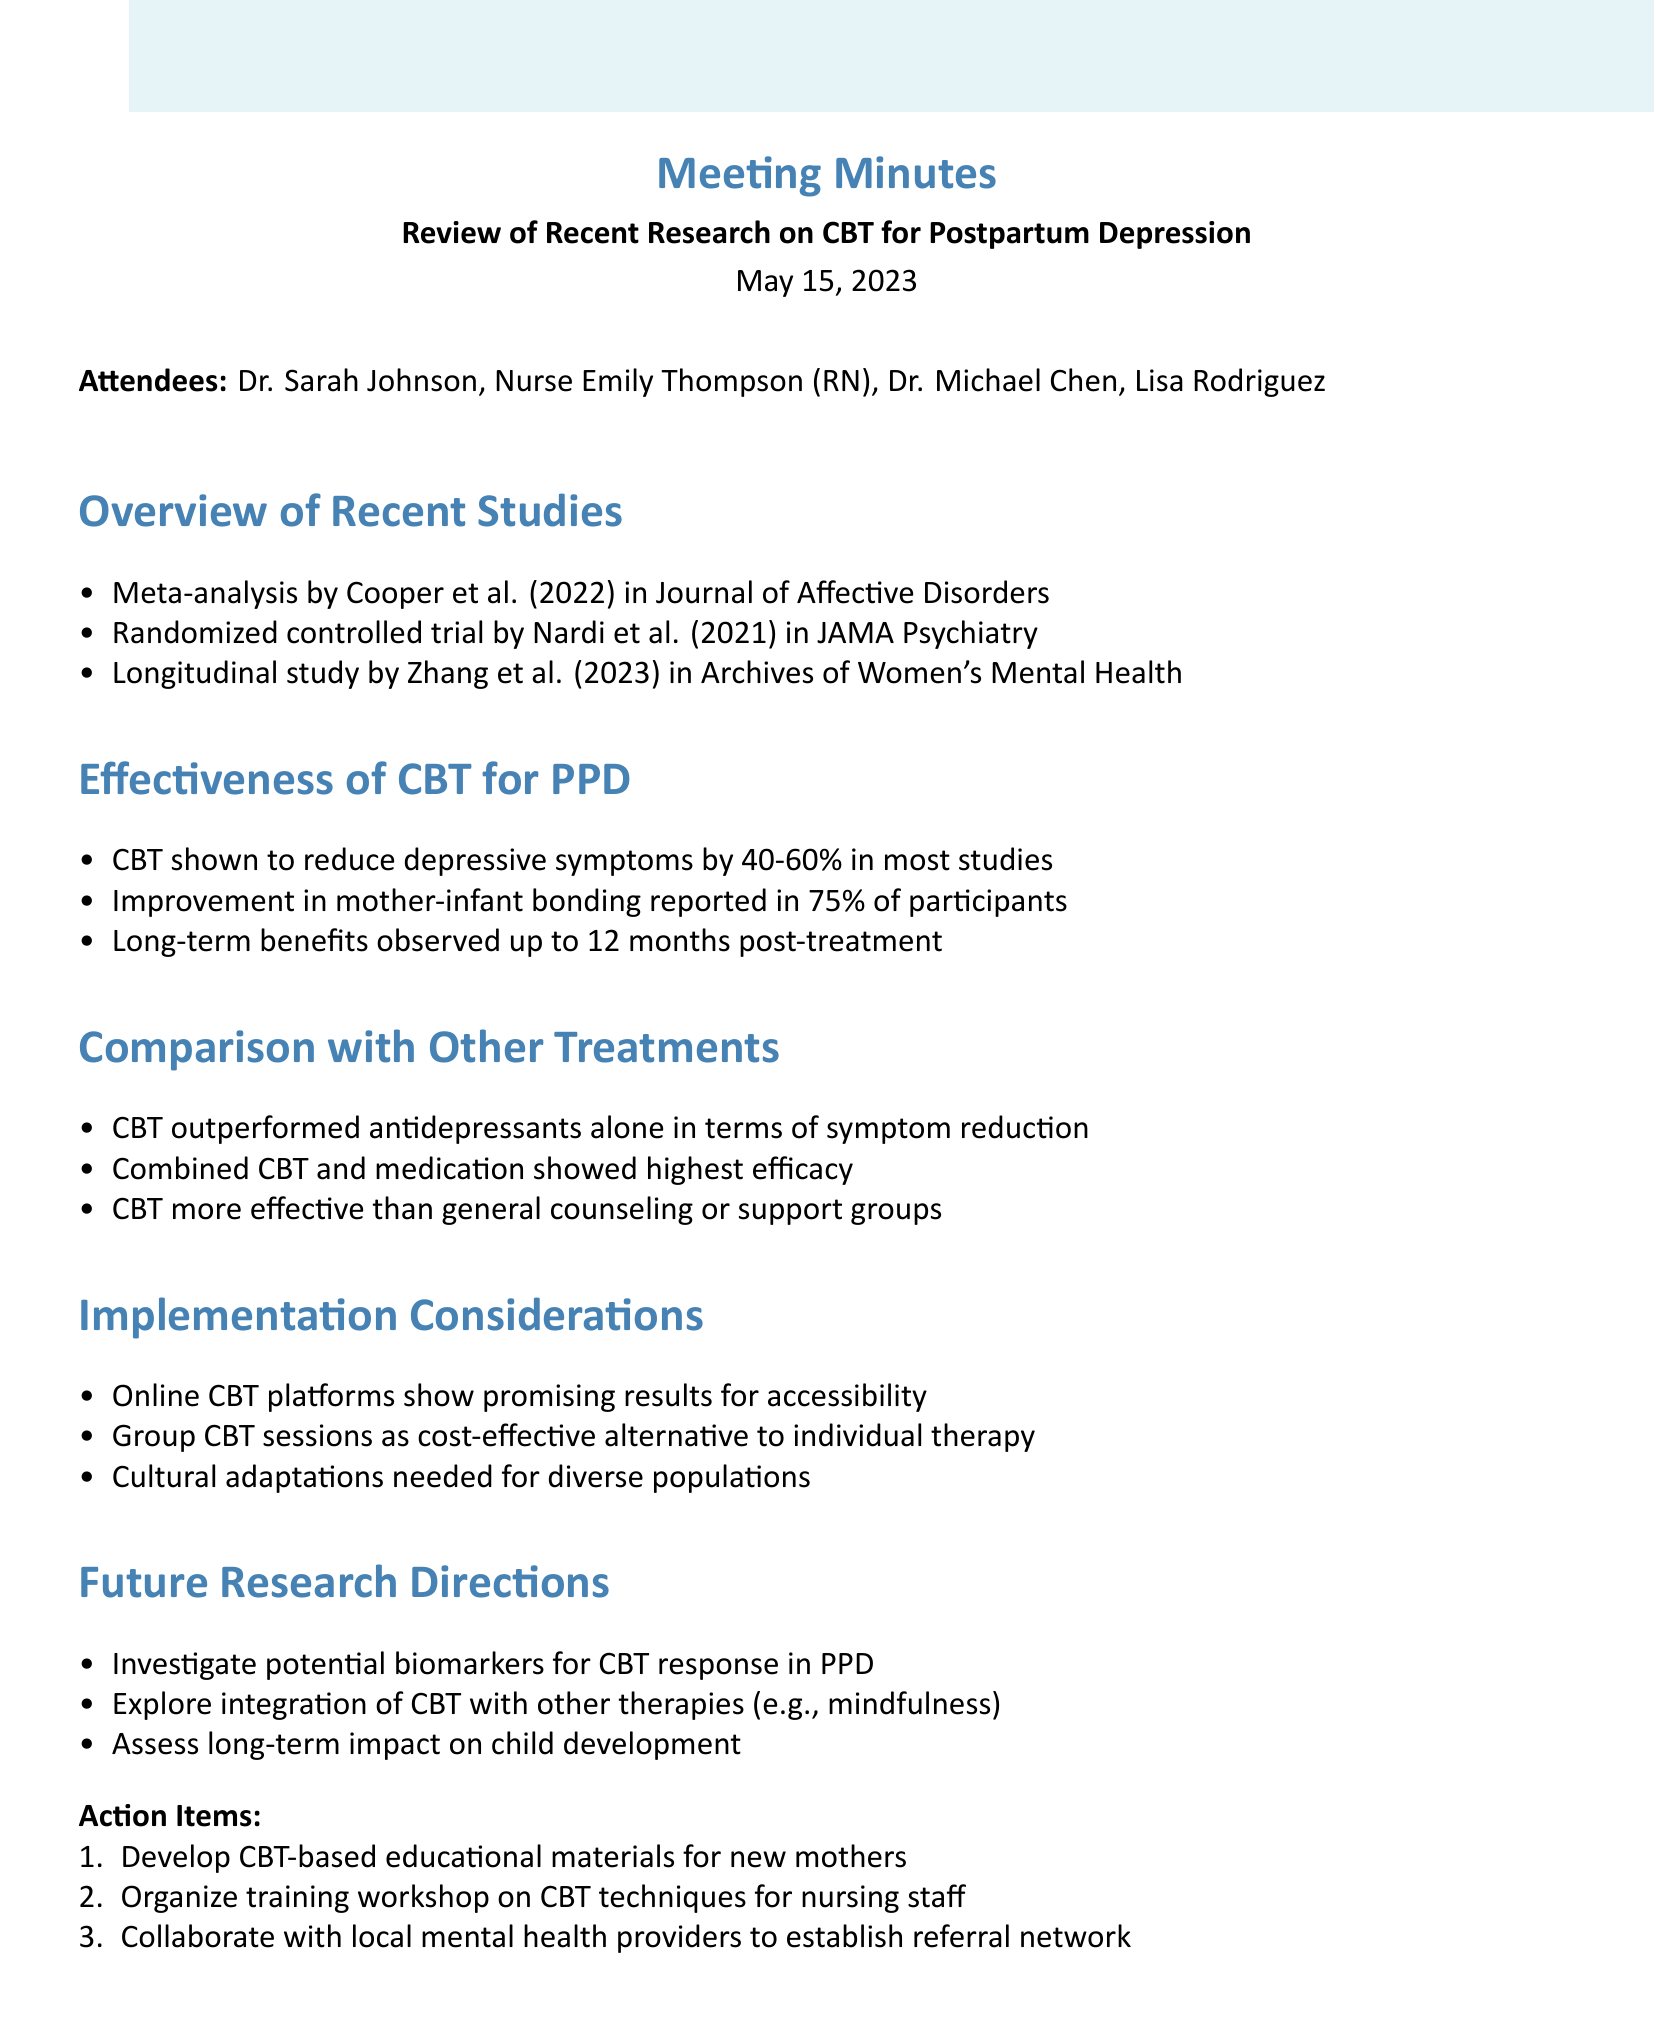what was the date of the meeting? The date of the meeting is provided in the document header, which states "May 15, 2023."
Answer: May 15, 2023 who are the attendees of the meeting? The names of attendees are listed right after the meeting date.
Answer: Dr. Sarah Johnson, Nurse Emily Thompson, Dr. Michael Chen, Lisa Rodriguez what percentage reduction in depressive symptoms was reported for CBT? The effectiveness section states that CBT can reduce depressive symptoms by "40-60% in most studies."
Answer: 40-60% which study was published in JAMA Psychiatry? The overview section mentions that the "Randomized controlled trial by Nardi et al. (2021) in JAMA Psychiatry" was discussed.
Answer: Nardi et al. (2021) what is one implementation consideration mentioned for CBT? The document specifically lists "Online CBT platforms show promising results for accessibility" as a consideration.
Answer: Online CBT platforms what combined treatment was found to be the most effective? According to the comparison section, it states "Combined CBT and medication showed highest efficacy."
Answer: Combined CBT and medication what is one future research direction suggested? One of the suggestions for future research is to "Investigate potential biomarkers for CBT response in PPD."
Answer: Investigate potential biomarkers how many action items were listed in the meeting minutes? The action items section lists three specific tasks to be completed.
Answer: 3 